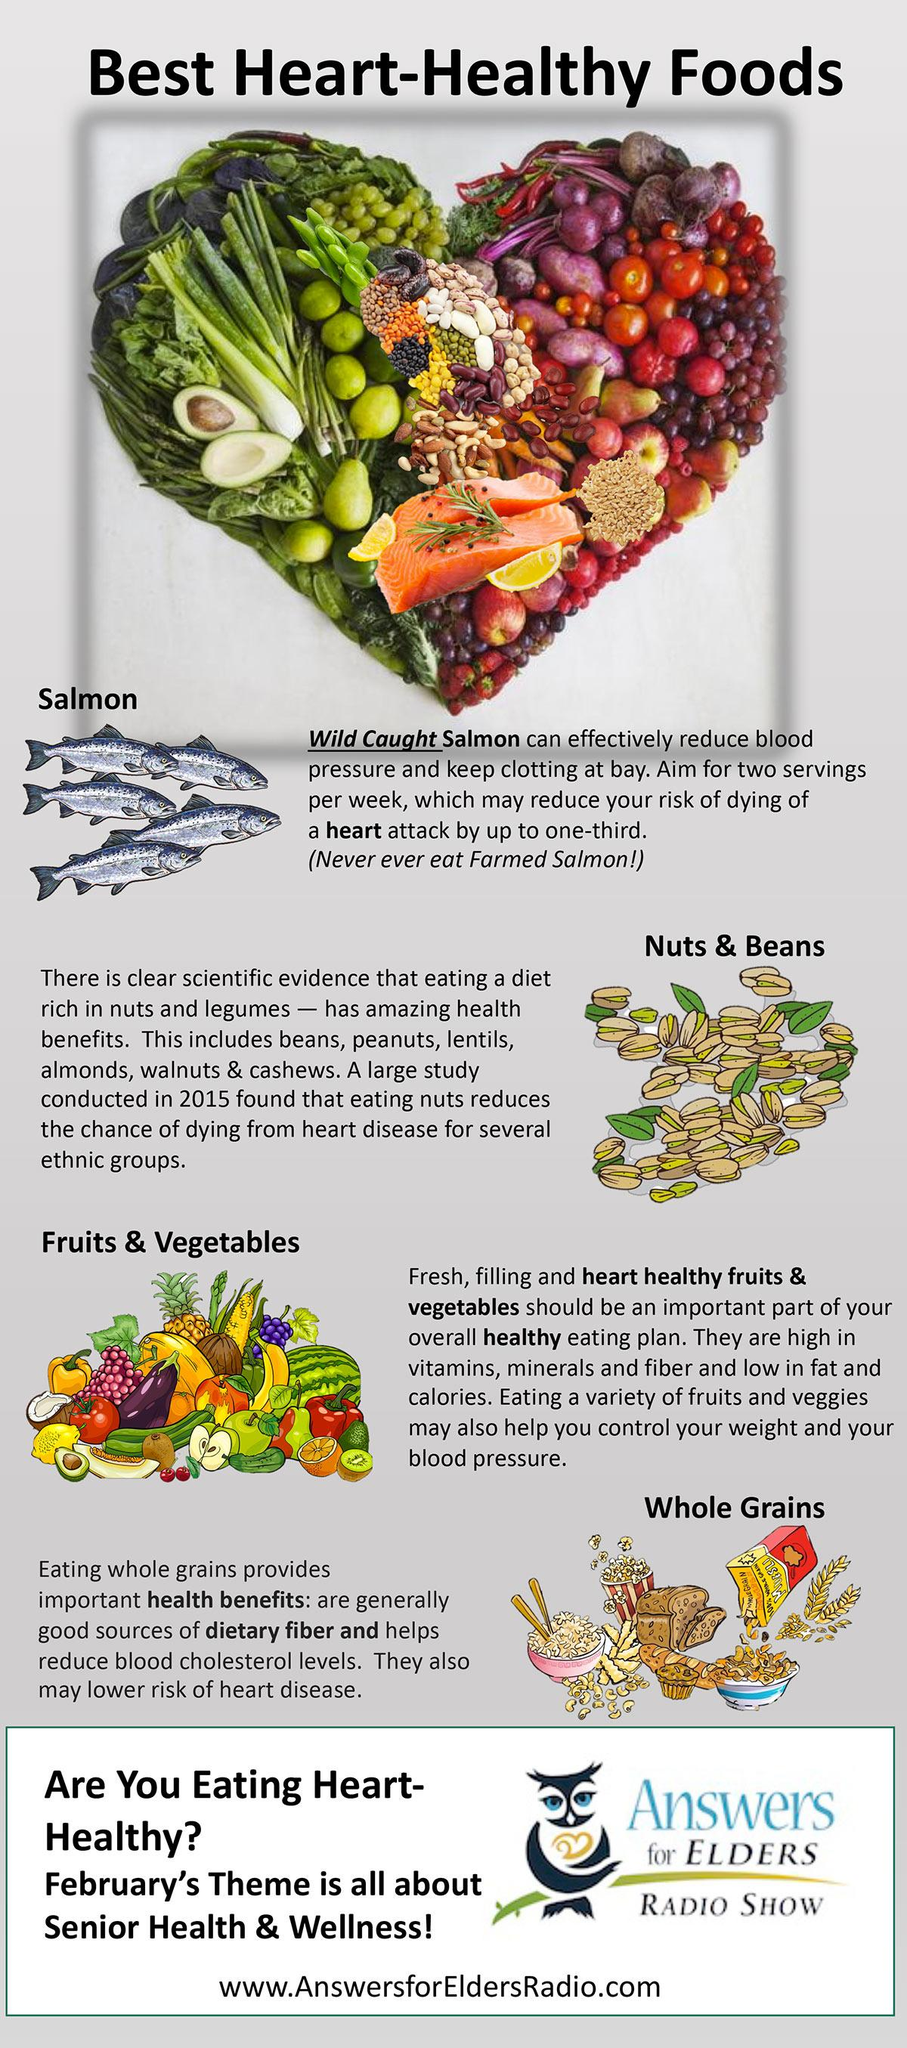Identify some key points in this picture. Four heart healthy foods are listed. Foods such as salmon, fruits, and vegetables have been shown to help lower blood pressure. 